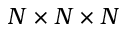<formula> <loc_0><loc_0><loc_500><loc_500>N \times N \times N</formula> 